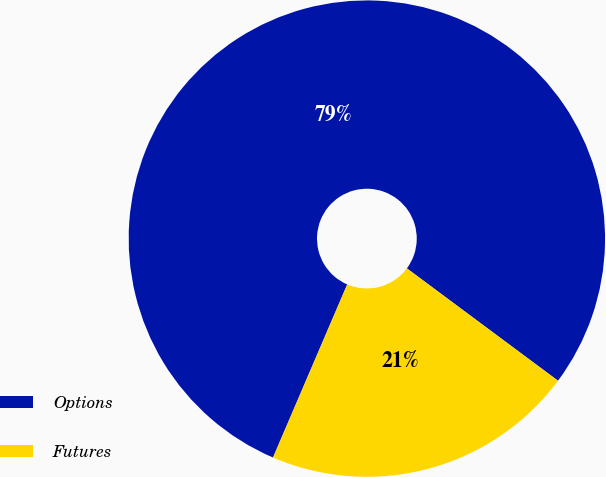Convert chart to OTSL. <chart><loc_0><loc_0><loc_500><loc_500><pie_chart><fcel>Options<fcel>Futures<nl><fcel>78.73%<fcel>21.27%<nl></chart> 